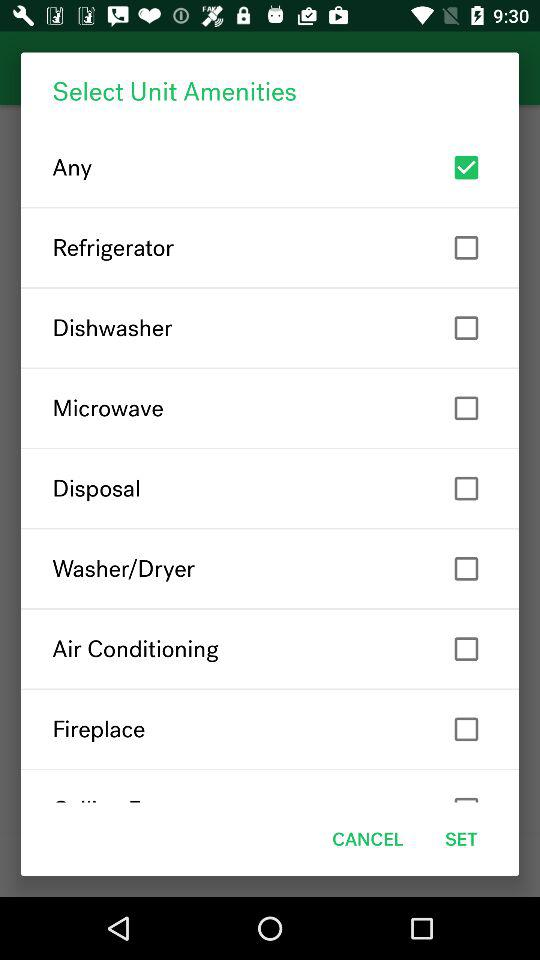How big is the fireplace?
When the provided information is insufficient, respond with <no answer>. <no answer> 